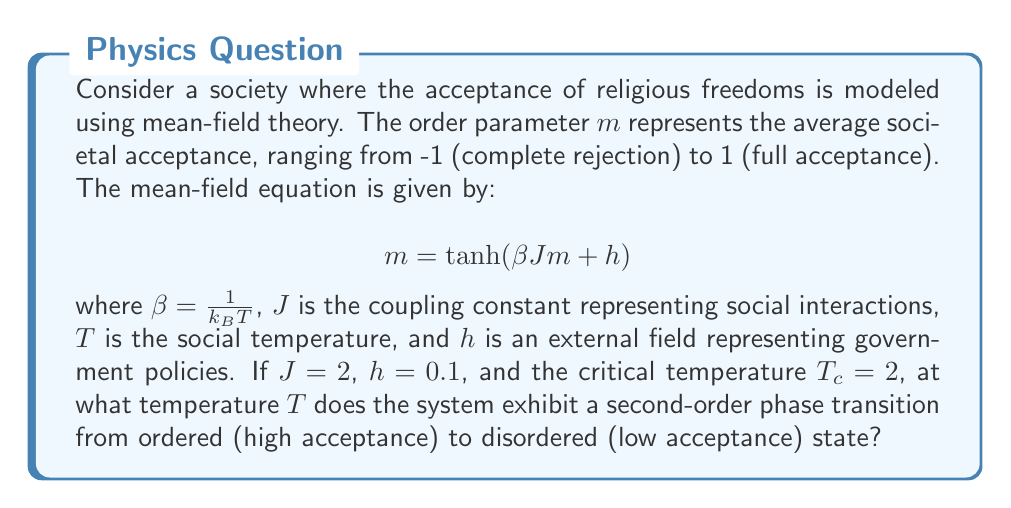What is the answer to this math problem? To solve this problem, we'll follow these steps:

1) In mean-field theory, the critical temperature $T_c$ is related to the coupling constant $J$ by:

   $$T_c = J$$

2) We're given that $T_c = 2$ and $J = 2$, which confirms this relationship.

3) At the critical point, the susceptibility diverges. This occurs when the slope of the tanh function at $m=0$ equals 1:

   $$\left.\frac{d}{dm}\tanh(\beta Jm + h)\right|_{m=0} = 1$$

4) Taking the derivative:

   $$\beta J \cdot \text{sech}^2(h) = 1$$

5) Substituting $\beta = \frac{1}{k_B T}$, $J = 2$, and $h = 0.1$:

   $$\frac{2}{k_B T} \cdot \text{sech}^2(0.1) = 1$$

6) Solving for $T$:

   $$T = \frac{2 \cdot \text{sech}^2(0.1)}{k_B}$$

7) Calculate $\text{sech}^2(0.1)$:

   $$\text{sech}^2(0.1) \approx 0.9900$$

8) Therefore:

   $$T = \frac{2 \cdot 0.9900}{k_B} \approx \frac{1.9800}{k_B}$$

This temperature $T$ is where the system transitions from ordered (high acceptance of religious freedoms) to disordered (low acceptance) state.
Answer: $T \approx \frac{1.9800}{k_B}$ 